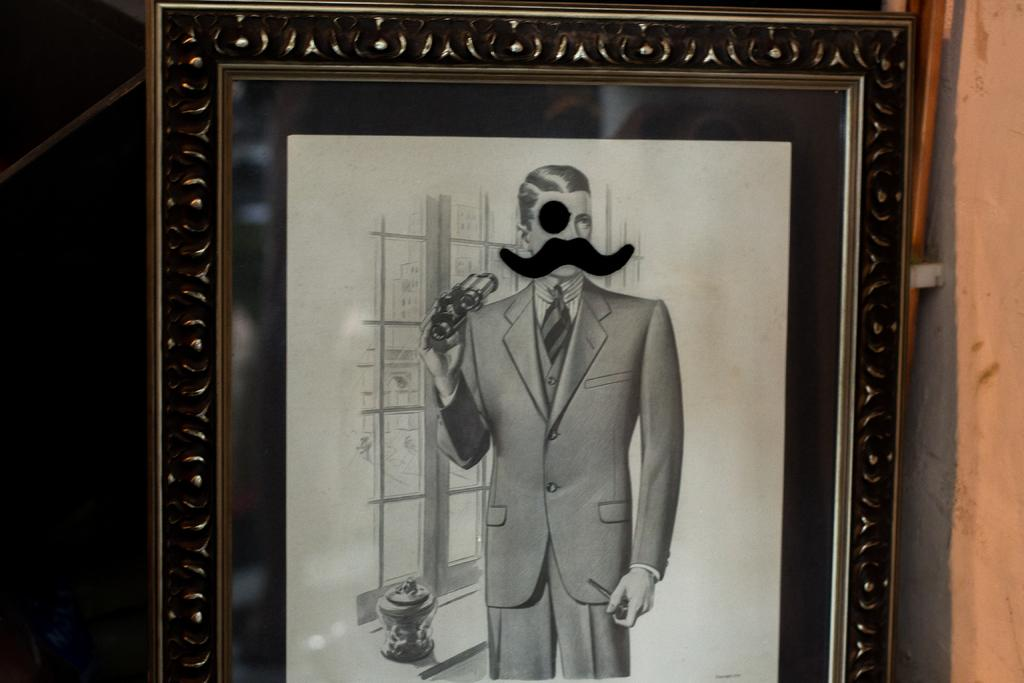What object is present in the image that typically holds a photograph? There is a photo frame in the image. What type of picture is displayed in the photo frame? The photo frame contains a black and white picture. Who is the subject of the picture in the photo frame? The picture is of a man. Can you tell me how many horses are visible in the image? There are no horses present in the image. Is there a lake visible in the background of the image? There is no lake visible in the image. 